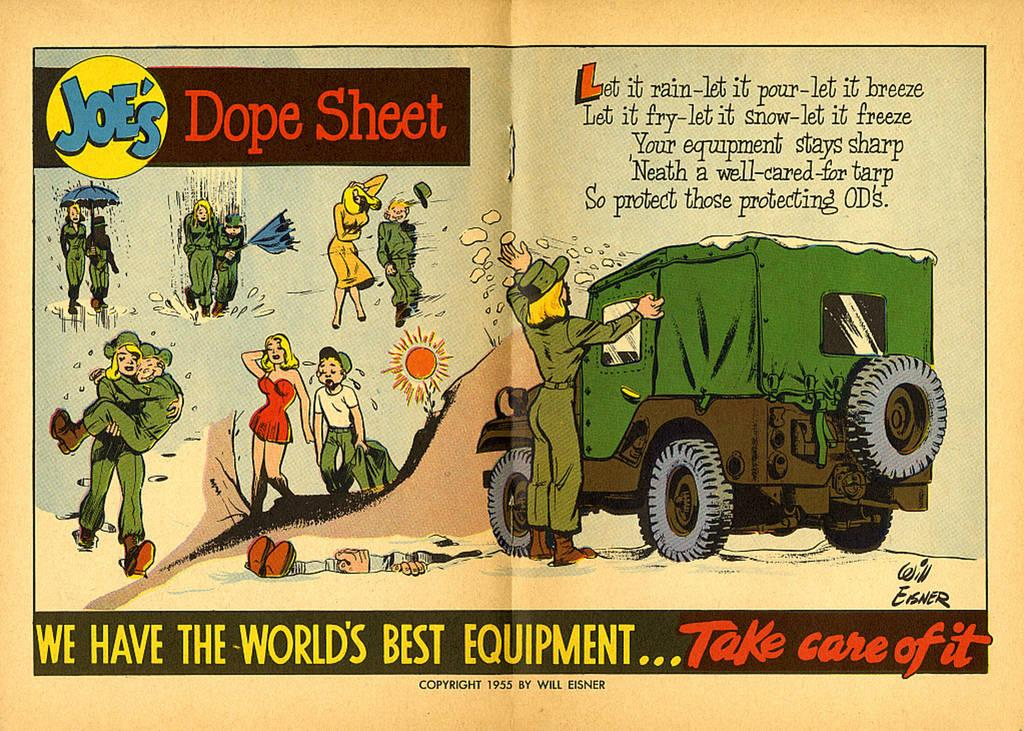What is happening in the image? There are people standing in the image. What else can be seen in the image besides the people? There is a car in the image. What type of oil is being used to fill the vase in the image? There is no vase or oil present in the image. 